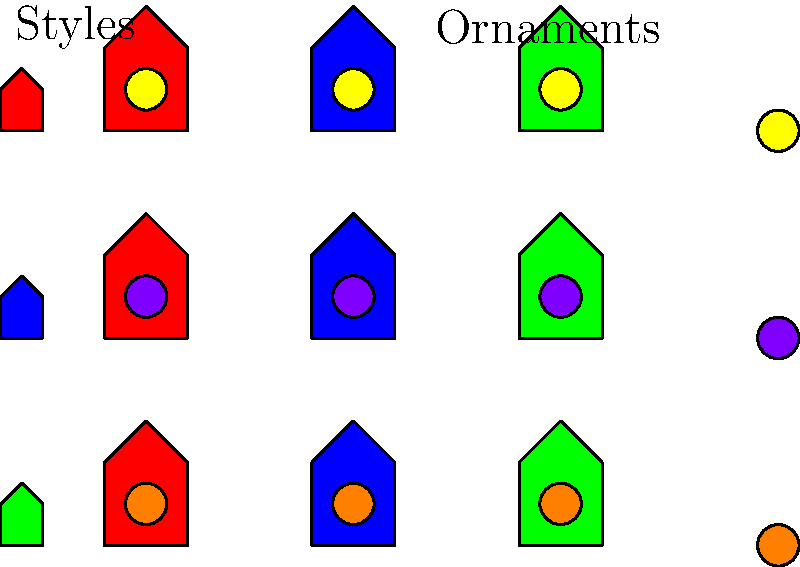In the diagram, birdhouse styles are represented by colors (red, blue, green) and ornamentation choices by circular decorations (yellow, purple, orange). If we consider the Cartesian product of the set of styles $S$ and the set of ornaments $O$, how many unique combinations of birdhouse styles and ornamentations are possible, and what does this represent in terms of group theory? To solve this problem, we need to follow these steps:

1. Identify the sets:
   Set $S$ (styles) = {red, blue, green}
   Set $O$ (ornaments) = {yellow, purple, orange}

2. Recall the definition of Cartesian product:
   The Cartesian product of two sets $A$ and $B$ is the set of all ordered pairs $(a,b)$ where $a \in A$ and $b \in B$.

3. Calculate the Cartesian product $S \times O$:
   $S \times O$ = {(red, yellow), (red, purple), (red, orange),
                   (blue, yellow), (blue, purple), (blue, orange),
                   (green, yellow), (green, purple), (green, orange)}

4. Count the number of elements in $S \times O$:
   $|S \times O| = |S| \times |O| = 3 \times 3 = 9$

5. Interpret in terms of group theory:
   - The set $S$ forms a group under some operation (e.g., combination of styles).
   - The set $O$ forms a group under some operation (e.g., combination of ornaments).
   - The Cartesian product $S \times O$ represents the direct product of these two groups.
   - Each element in $S \times O$ represents a unique combination of a style and an ornament.
   - The order of the resulting group $S \times O$ is the product of the orders of $S$ and $O$.

Therefore, there are 9 unique combinations, representing the elements of the direct product group formed by combining the style and ornament groups.
Answer: 9 combinations; direct product group 